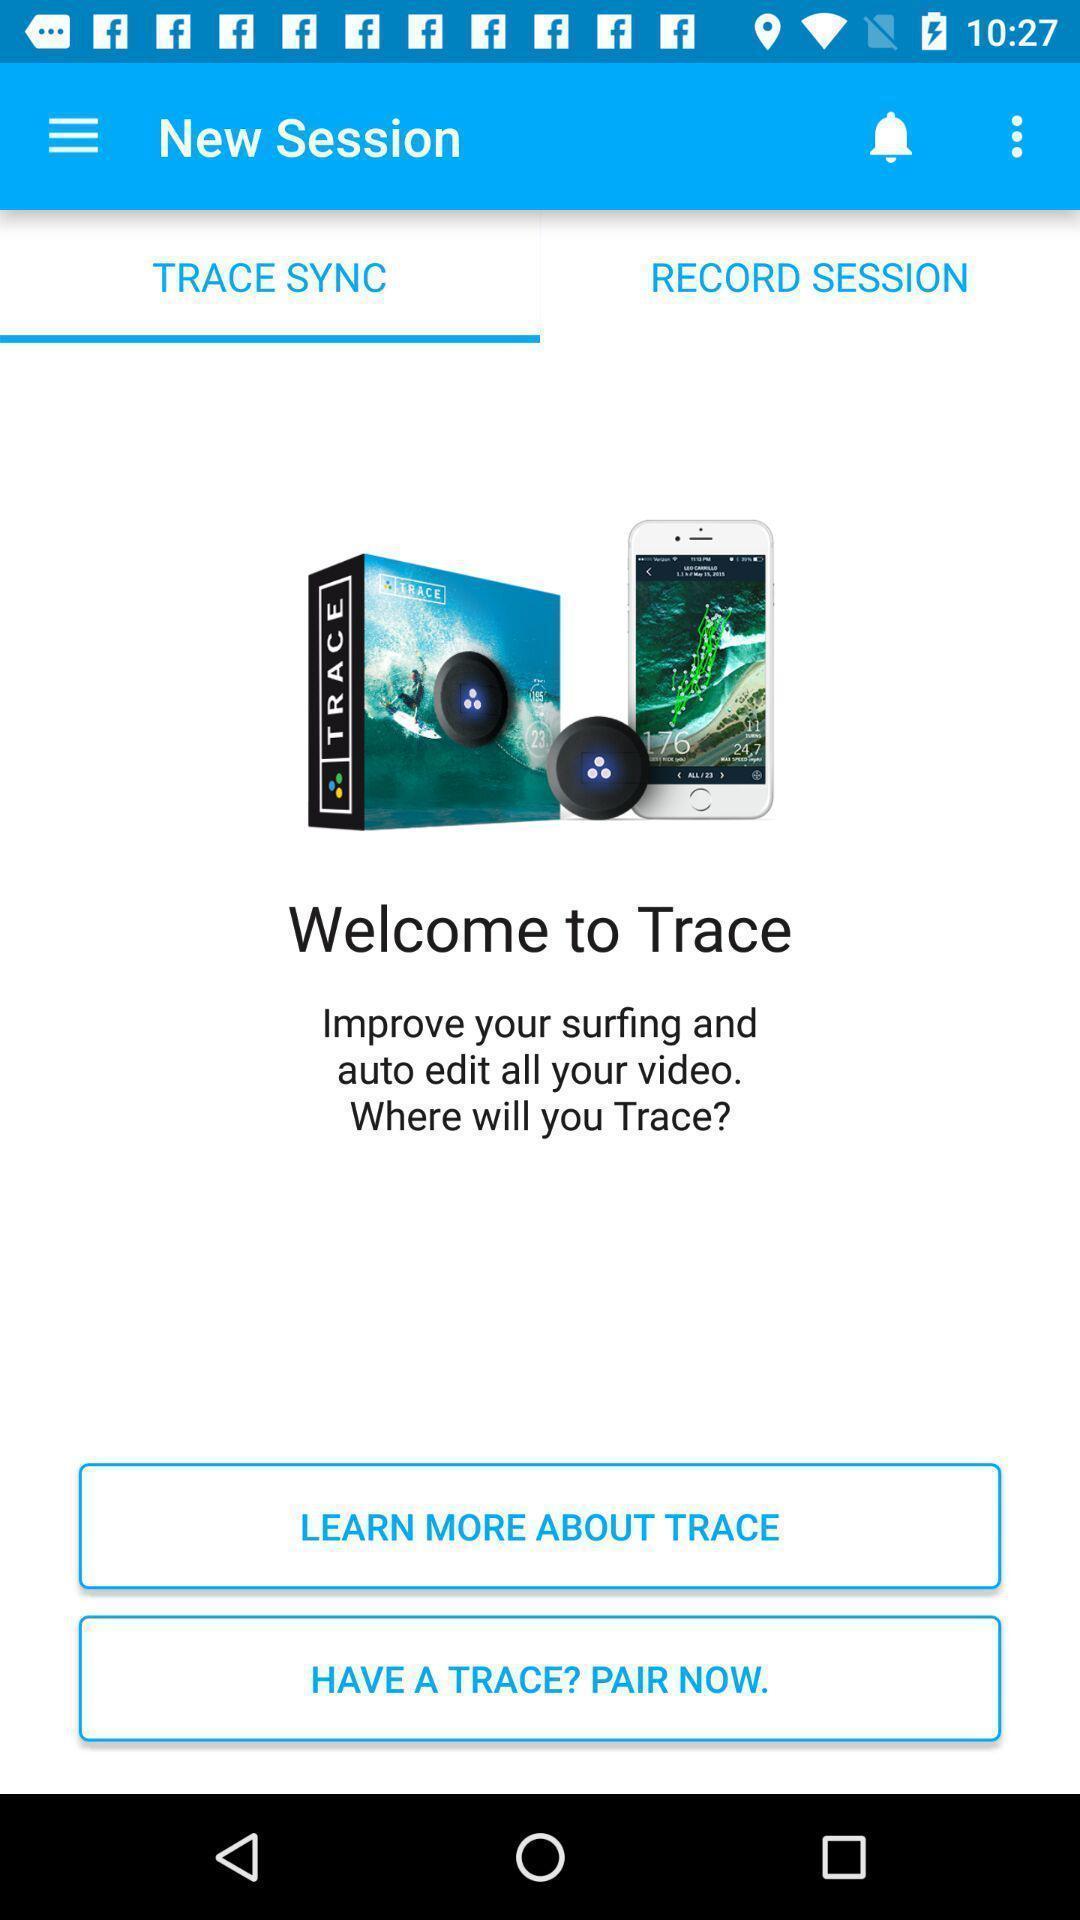Tell me what you see in this picture. Welcome to trace in trace sync in new session. 